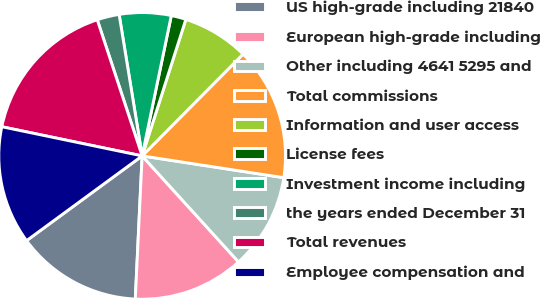Convert chart. <chart><loc_0><loc_0><loc_500><loc_500><pie_chart><fcel>US high-grade including 21840<fcel>European high-grade including<fcel>Other including 4641 5295 and<fcel>Total commissions<fcel>Information and user access<fcel>License fees<fcel>Investment income including<fcel>the years ended December 31<fcel>Total revenues<fcel>Employee compensation and<nl><fcel>14.17%<fcel>12.5%<fcel>10.83%<fcel>15.0%<fcel>7.5%<fcel>1.67%<fcel>5.83%<fcel>2.5%<fcel>16.67%<fcel>13.33%<nl></chart> 